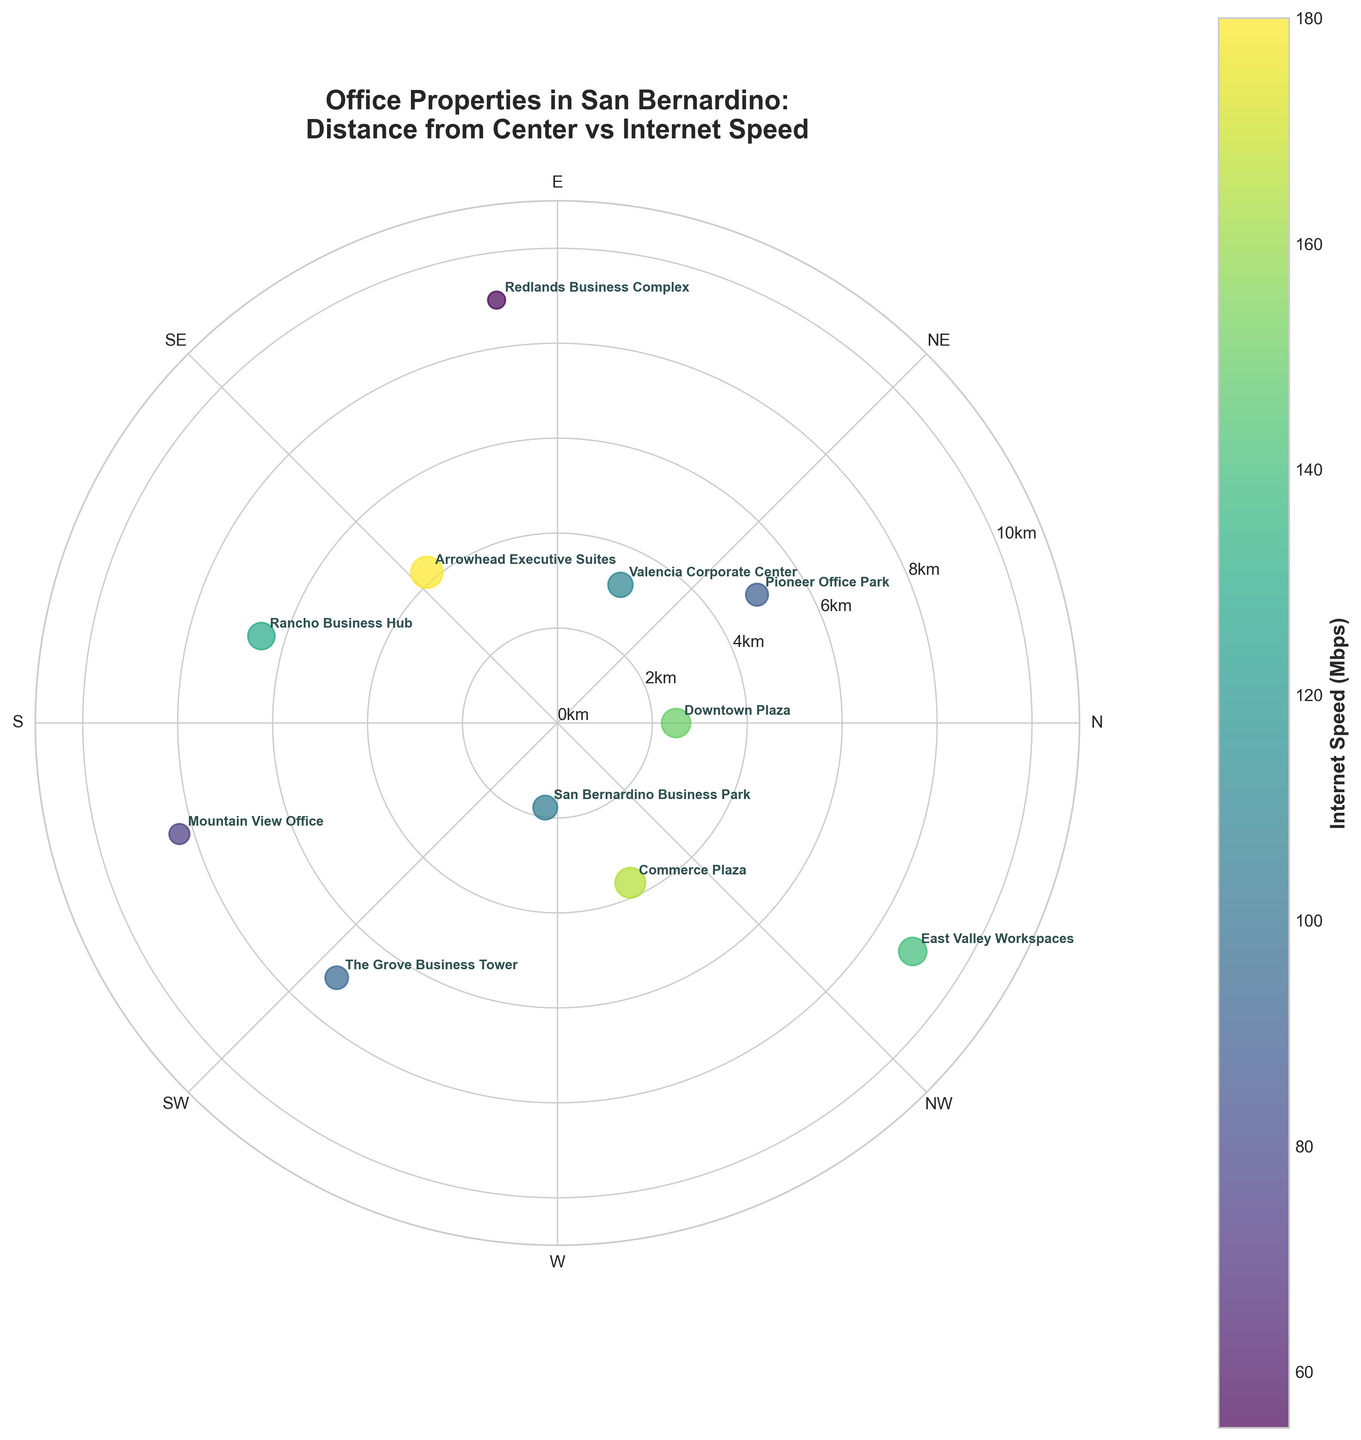What's the title of the figure? The title is usually placed at the top of the figure and provides a concise description of what the figure represents. In this case, it mentions the office properties in San Bernardino, their distance from the center, and their internet speeds.
Answer: Office Properties in San Bernardino: Distance from Center vs Internet Speed How many office properties are shown in the figure? Each point on the scatter plot represents an office property. By counting these points, we can determine the number of properties depicted in the figure.
Answer: 11 Which property has the highest internet speed, and what is that speed? Look for the largest point with the darkest color, as sizes correspond to internet speeds. The "Arrowhead Executive Suites" has the highest value.
Answer: Arrowhead Executive Suites, 180 Mbps What is the distance from the center for "Redlands Business Complex"? Identify the radial distance (r) for the property "Redlands Business Complex" by finding its label on the plot and reading the value on the radial axis.
Answer: 9 km Which property is closest to the center, and what is its internet speed? Find the property with the smallest radial distance (r) from the center and check its corresponding internet speed.
Answer: San Bernardino Business Park, 105 Mbps What's the median internet speed among the properties? First, list all internet speeds and then find the middle value when they are sorted. Speeds are: 55, 75, 90, 95, 105, 110, 130, 140, 150, 165, 180. The median is the middle value of this sorted list.
Answer: 110 Mbps Compare the internet speeds of "Valencia Corporate Center" and "Rancho Business Hub" – which one is higher? Find both properties on the plot and compare their internet speeds. "Valencia Corporate Center" has 110 Mbps, and "Rancho Business Hub" has 130 Mbps.
Answer: Rancho Business Hub What is the average internet speed of the properties located more than 5 km from the center? Identify properties with distances greater than 5 km (Pioneer Office Park, Redlands Business Complex, Rancho Business Hub, Mountain View Office, The Grove Business Tower, East Valley Workspaces), sum their internet speeds (90 + 55 + 130 + 75 + 95 + 140), and divide by the number of these properties.
Answer: 97.5 Mbps Which quadrant (N, NE, E, SE, S, SW, W, NW) has the most office properties? Count the number of properties in each directional segment (N, NE, E, SE, S, SW, W, NW) by observing their angles on the polar chart.
Answer: NE and SE (tied) For "Commerce Plaza," how does its internet speed compare to the average internet speed of all properties? Calculate the average speed of all properties (150 + 90 + 110 + 55 + 180 + 130 + 75 + 95 + 105 + 165 + 140) / 11 and compare it with Commerce Plaza’s speed (165 Mbps). The average is approximately 118.64 Mbps.
Answer: Higher 